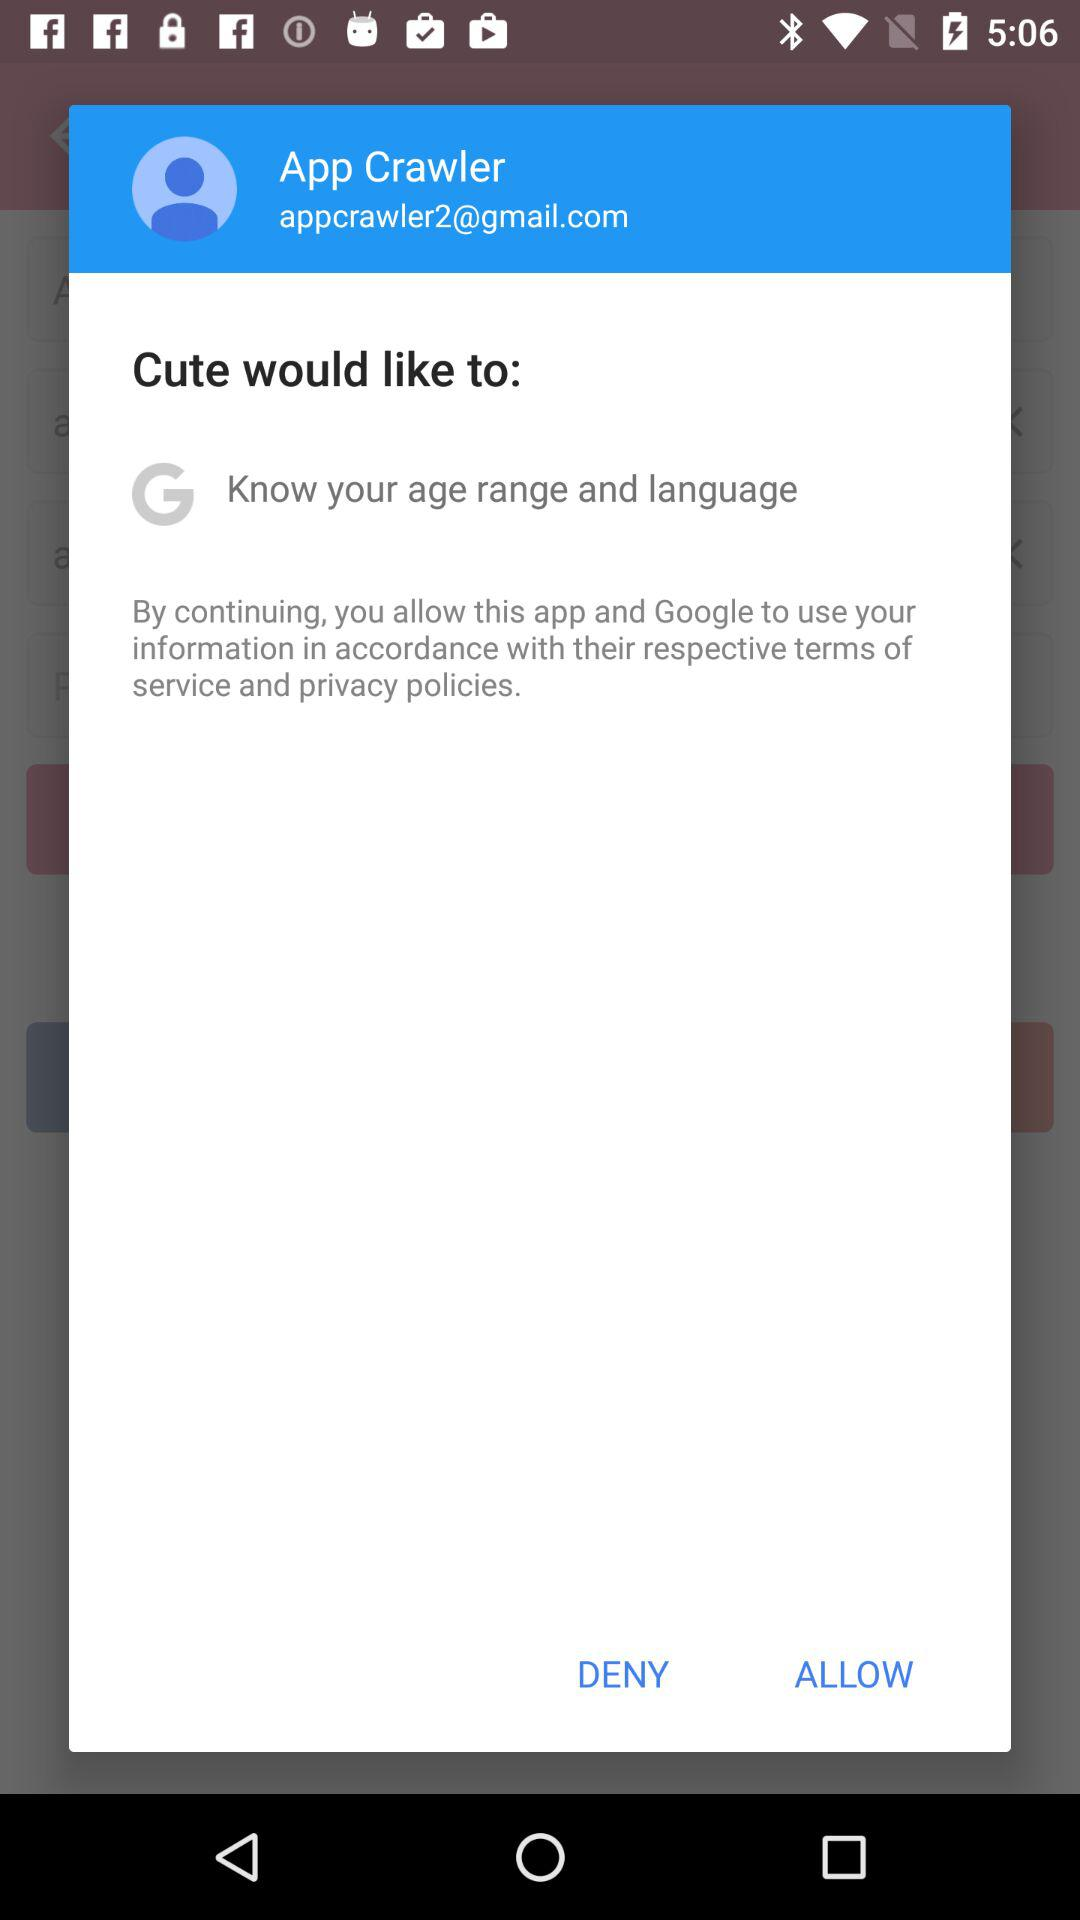What is the email address of the user? The email address of the user is appcrawler2@gmail.com. 